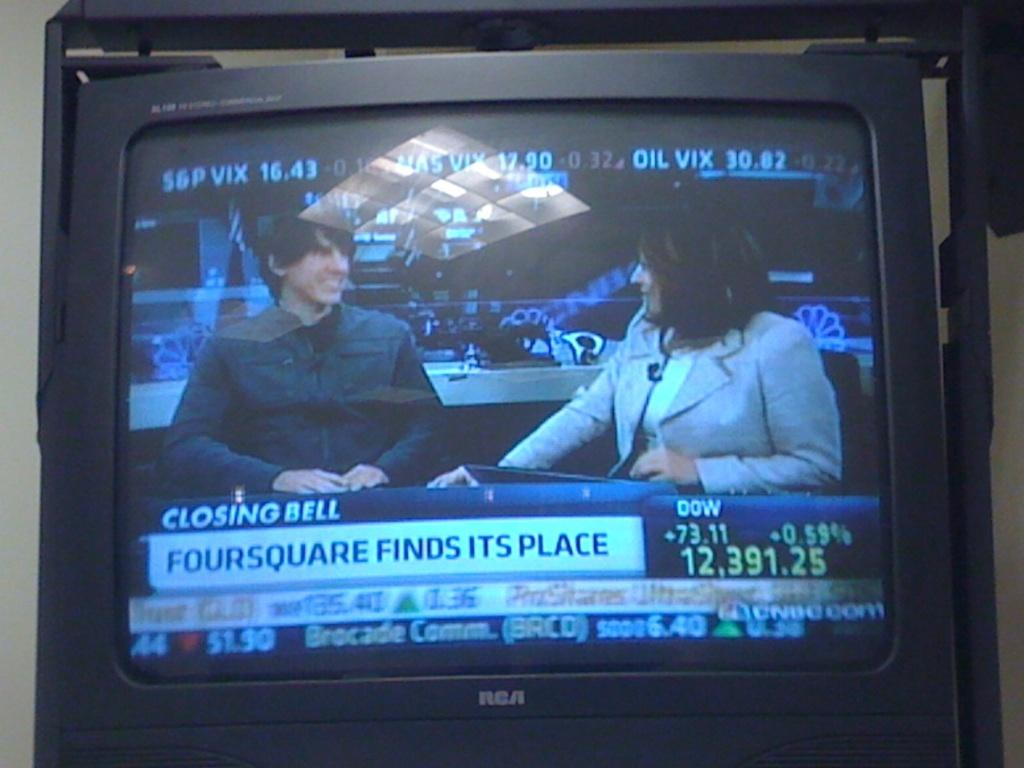<image>
Describe the image concisely. a foursquare ad at the bottom of a screen 